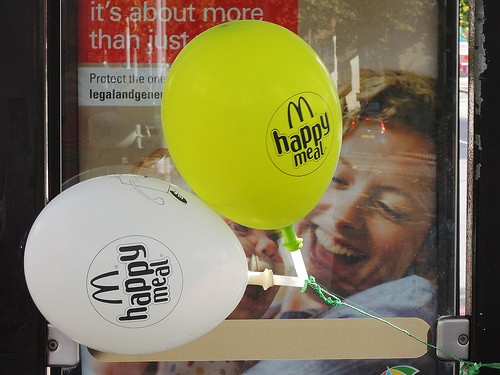<image>
Can you confirm if the yellow balloon is next to the white ballon? Yes. The yellow balloon is positioned adjacent to the white ballon, located nearby in the same general area. 